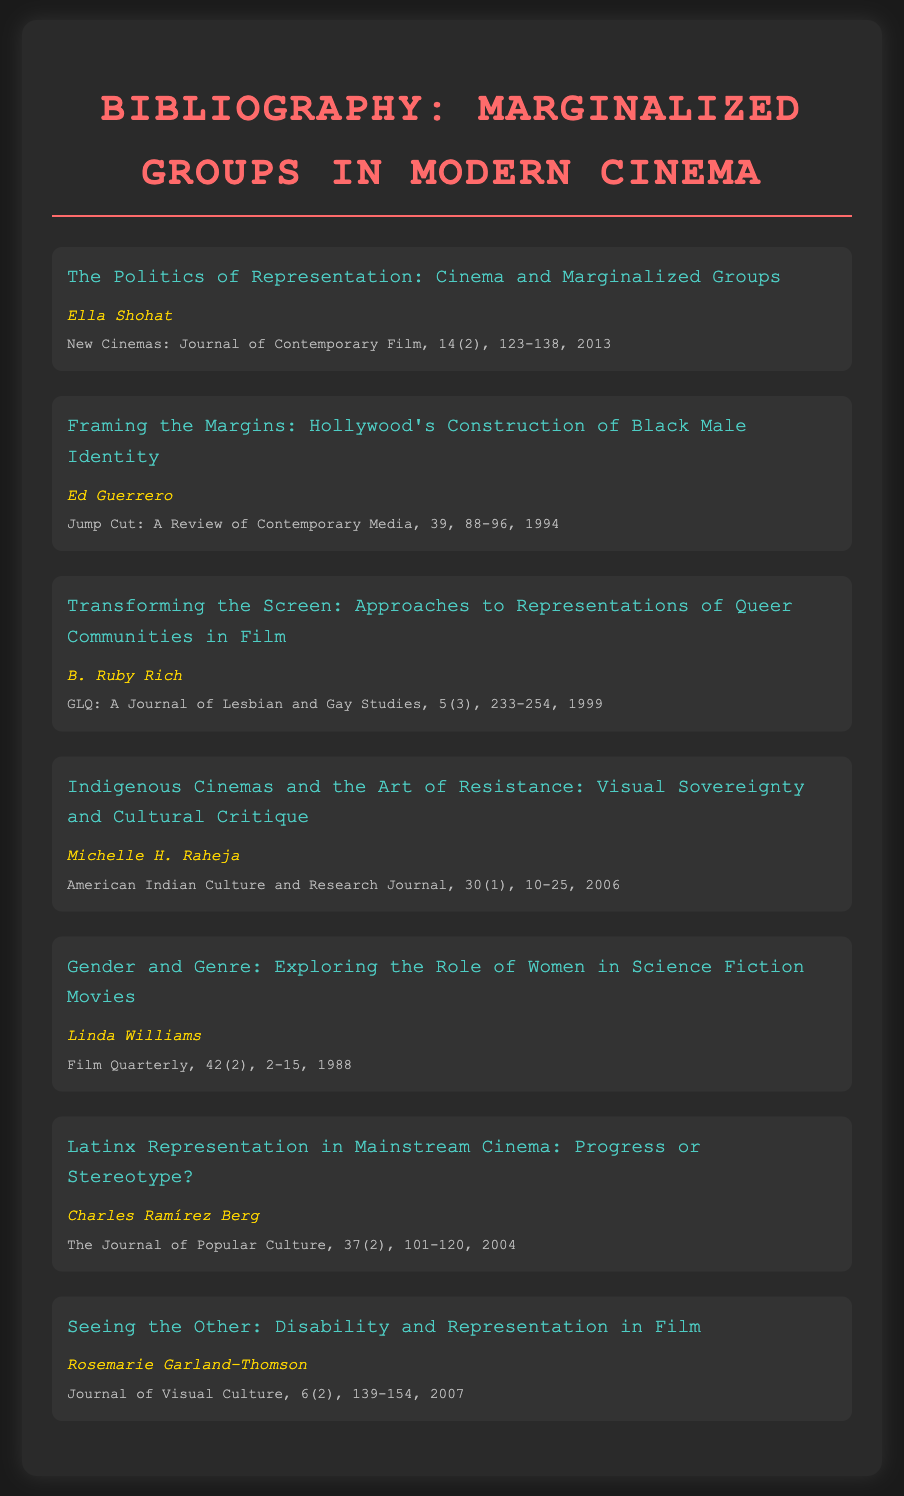What is the title of the first entry? The title of the first entry is found at the top of the first bibliography entry.
Answer: The Politics of Representation: Cinema and Marginalized Groups Who is the author of the article on Latinx representation? The author of the article on Latinx representation is listed beneath its title.
Answer: Charles Ramírez Berg What journal published the article by Ed Guerrero? The journal in which Ed Guerrero's article was published is mentioned at the end of the entry.
Answer: Jump Cut: A Review of Contemporary Media In what year was the article on seeing disability in film published? The year of publication is stated in the details of the specific entry for this article.
Answer: 2007 How many articles are cited by Michelle H. Raheja? The total number of articles is found by counting the individual bibliography entries.
Answer: One What is the volume number of the article by B. Ruby Rich? The volume number can be found in the details section of Rich's entry.
Answer: 5 What common theme is present in all the bibliographic entries? The theme can be inferred from the titles and authors focusing on marginalized groups in cinema.
Answer: Representation 